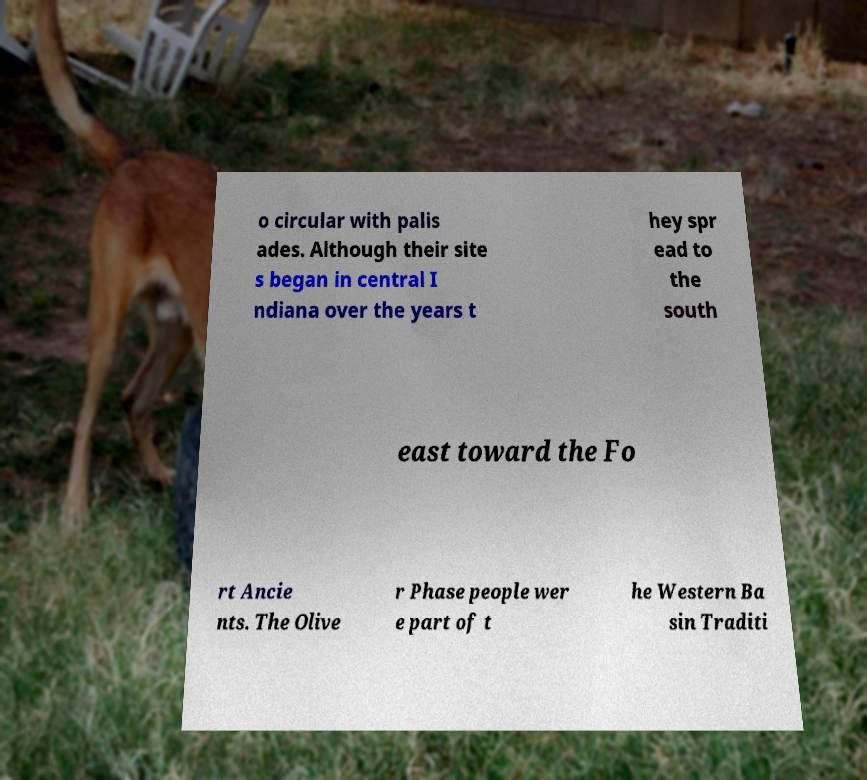There's text embedded in this image that I need extracted. Can you transcribe it verbatim? o circular with palis ades. Although their site s began in central I ndiana over the years t hey spr ead to the south east toward the Fo rt Ancie nts. The Olive r Phase people wer e part of t he Western Ba sin Traditi 